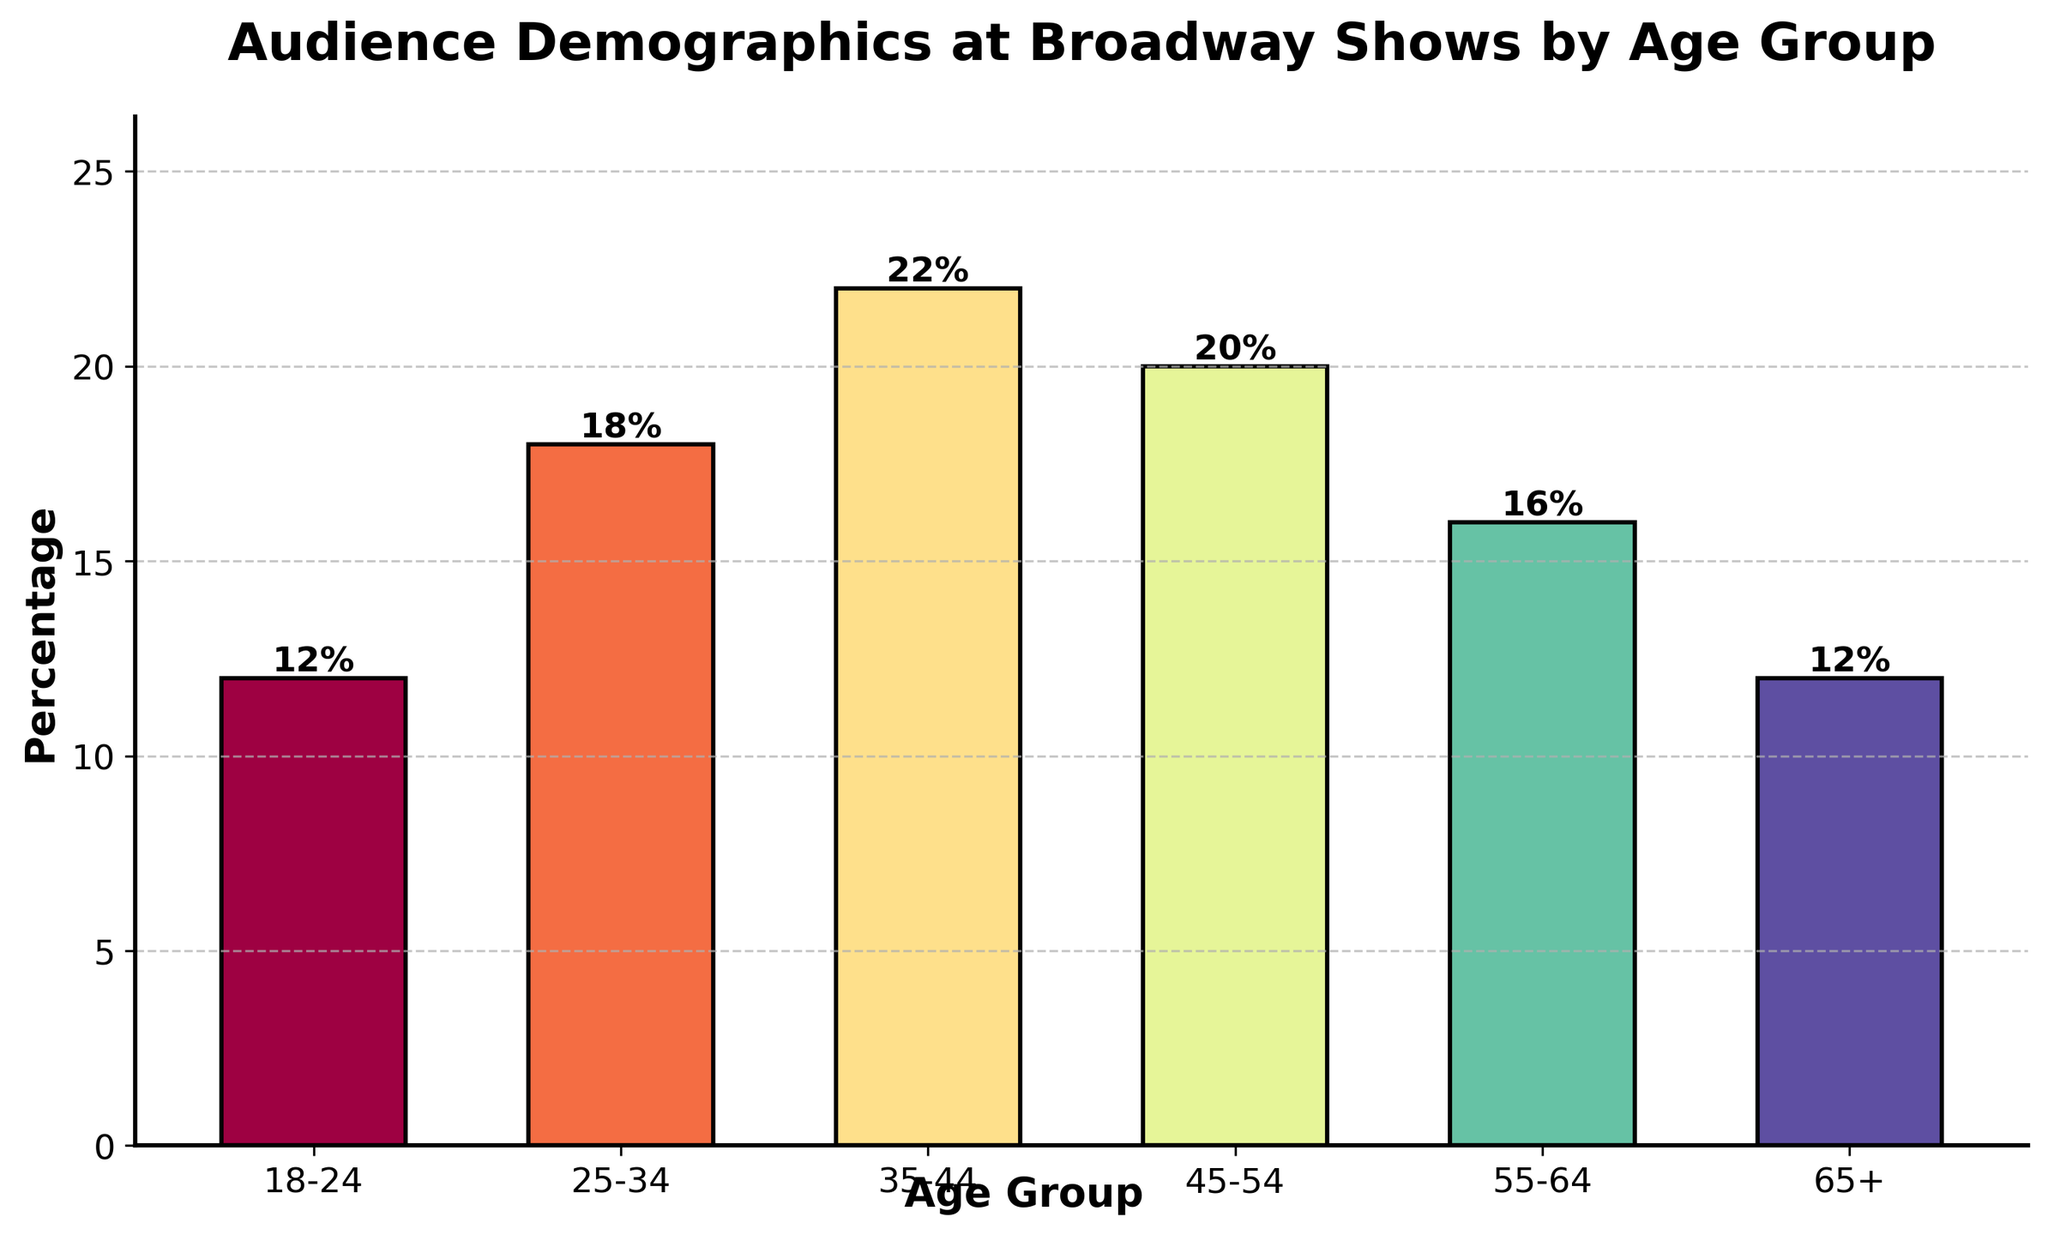What age group has the highest percentage of audience? To find the age group with the highest percentage, we look for the tallest bar in the bar chart. The age group 35-44 has the highest bar, indicating the highest percentage.
Answer: 35-44 What is the combined percentage of the audience in the 18-24 and 65+ age groups? Add the percentages for the 18-24 age group (12%) and the 65+ age group (12%). 12% + 12% = 24%.
Answer: 24% Which age group has a lower percentage of audience: 55-64 or 25-34? Compare the heights of the bars for the 55-64 and 25-34 age groups. The bar for 55-64 is lower with 16%, and the bar for 25-34 is higher with 18%.
Answer: 55-64 How much more percentage of the audience is in the 45-54 age group compared to the 65+ age group? Subtract the percentage of the 65+ age group (12%) from the percentage of the 45-54 age group (20%). 20% - 12% = 8%.
Answer: 8% What is the average percentage of audience across all age groups? Sum all the percentages (12% + 18% + 22% + 20% + 16% + 12%) and divide by the number of age groups (6). (12 + 18 + 22 + 20 + 16 + 12) / 6 = 16.67%
Answer: 16.67% Which age groups have the same percentage of the audience? Identify bars of the same height. The bars for the age groups 18-24 and 65+ both have a height of 12%.
Answer: 18-24, 65+ How does the percentage of the 35-44 age group compare to the 55-64 age group? Compare the heights of the bars for the 35-44 and the 55-64 age groups. The 35-44 age group (22%) has a higher percentage than the 55-64 age group (16%).
Answer: Greater If we combined the 18-24 and 25-34 age groups into one, what would their combined percentage be? Add the percentages for the 18-24 age group (12%) and the 25-34 age group (18%). 12% + 18% = 30%.
Answer: 30% What is the difference in percentage between the highest and lowest age groups? Subtract the percentage of the lowest age group (12% for 18-24 and 65+) from the highest age group (22% for 35-44). 22% - 12% = 10%.
Answer: 10% 